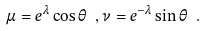Convert formula to latex. <formula><loc_0><loc_0><loc_500><loc_500>\mu = e ^ { \lambda } \cos \theta \ , \nu = e ^ { - \lambda } \sin \theta \ .</formula> 